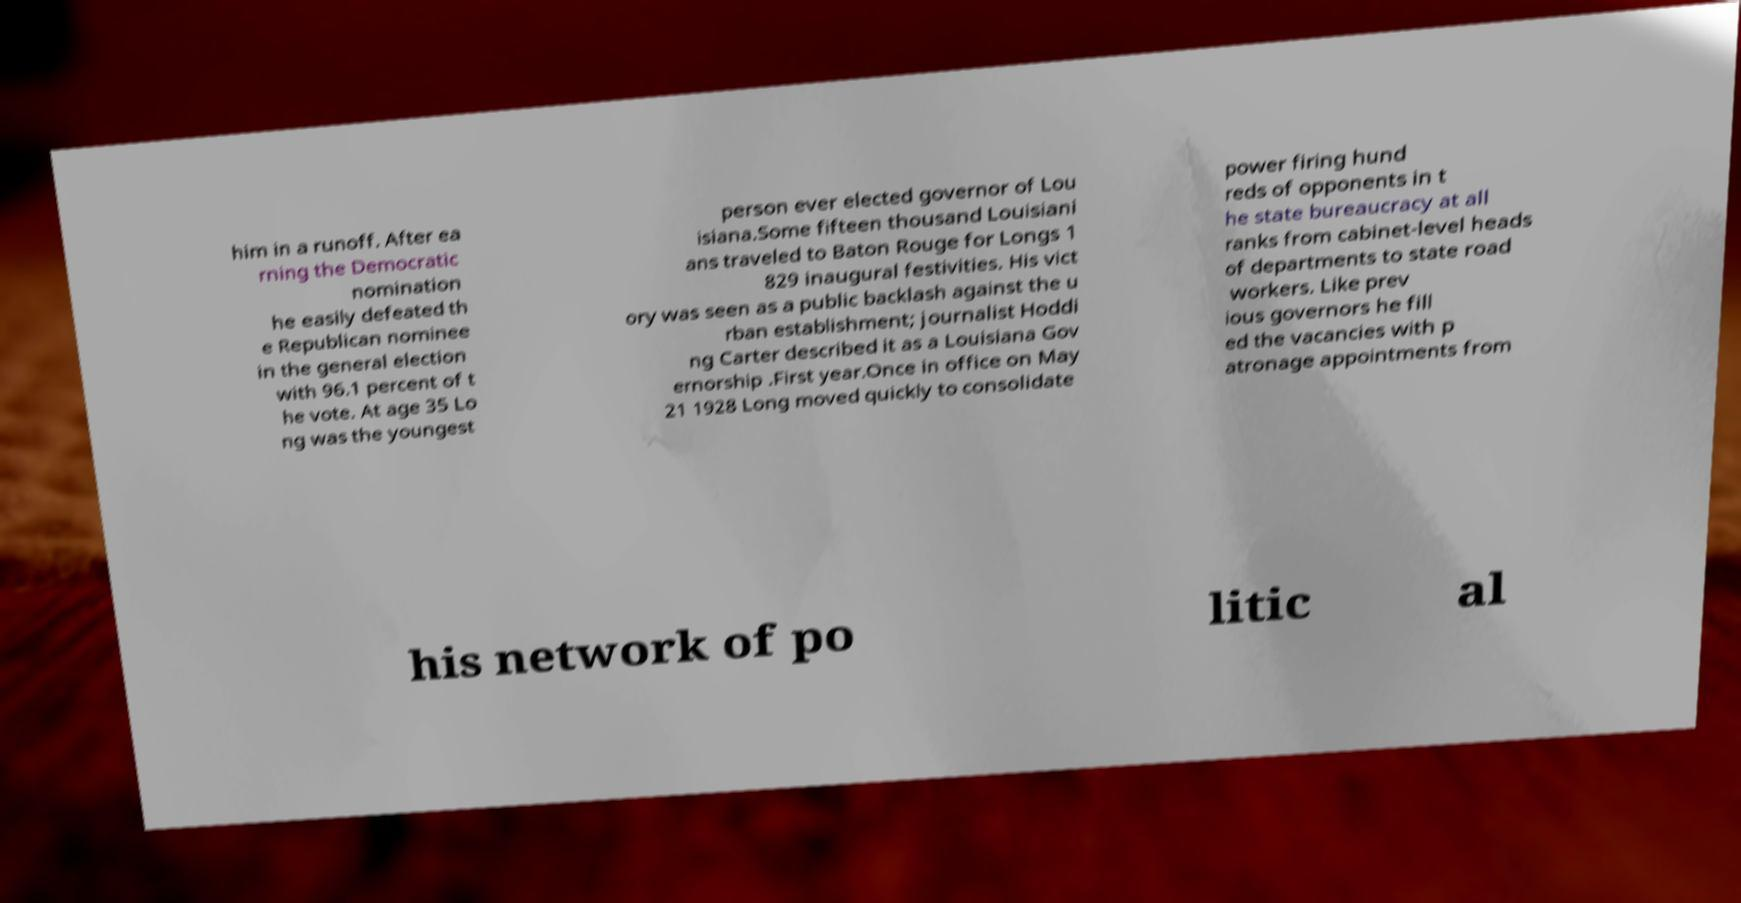Please read and relay the text visible in this image. What does it say? him in a runoff. After ea rning the Democratic nomination he easily defeated th e Republican nominee in the general election with 96.1 percent of t he vote. At age 35 Lo ng was the youngest person ever elected governor of Lou isiana.Some fifteen thousand Louisiani ans traveled to Baton Rouge for Longs 1 829 inaugural festivities. His vict ory was seen as a public backlash against the u rban establishment; journalist Hoddi ng Carter described it as a Louisiana Gov ernorship .First year.Once in office on May 21 1928 Long moved quickly to consolidate power firing hund reds of opponents in t he state bureaucracy at all ranks from cabinet-level heads of departments to state road workers. Like prev ious governors he fill ed the vacancies with p atronage appointments from his network of po litic al 